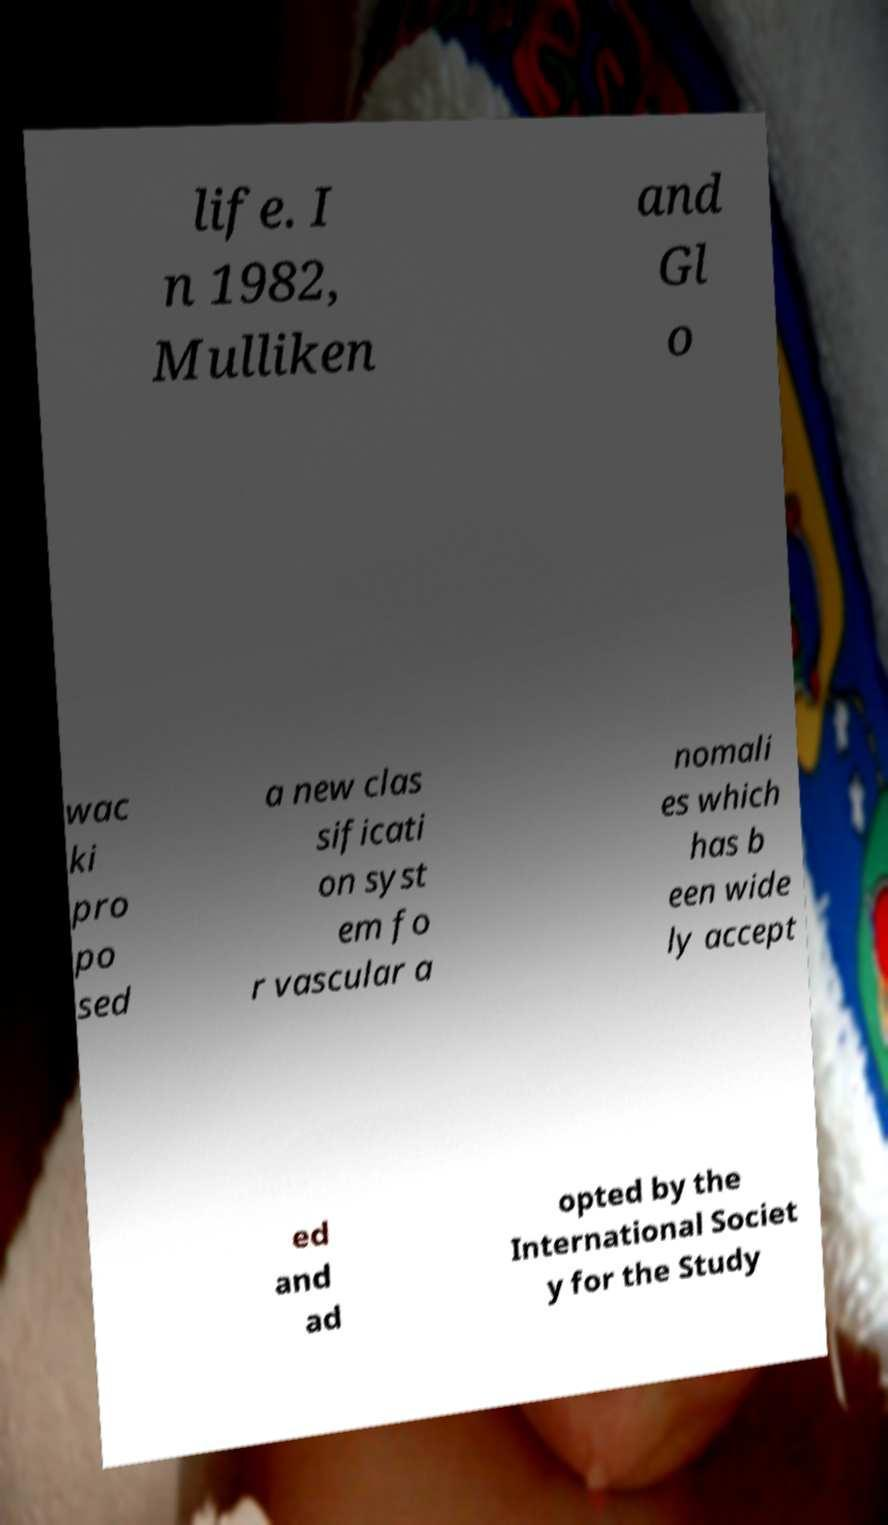Could you extract and type out the text from this image? life. I n 1982, Mulliken and Gl o wac ki pro po sed a new clas sificati on syst em fo r vascular a nomali es which has b een wide ly accept ed and ad opted by the International Societ y for the Study 